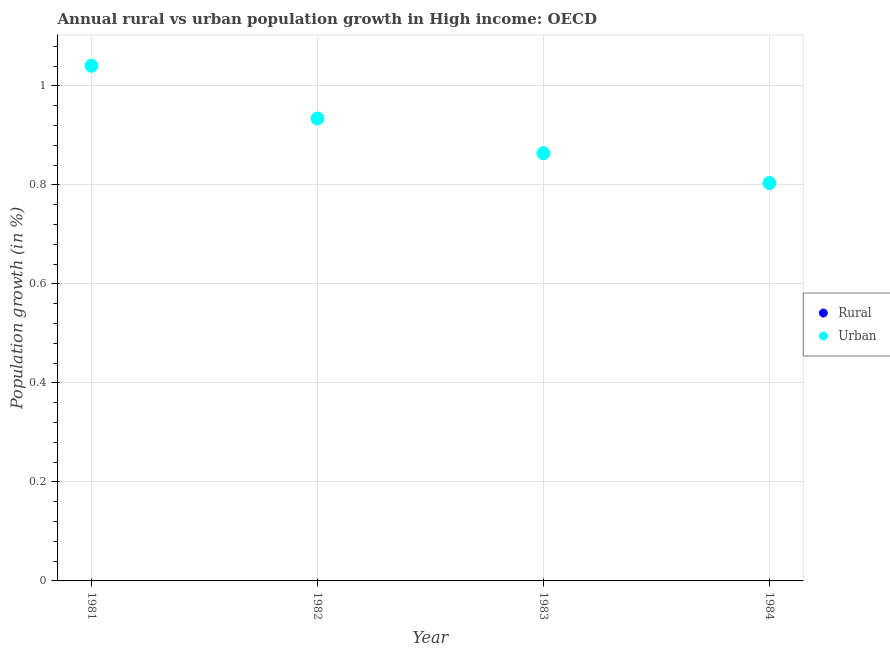Is the number of dotlines equal to the number of legend labels?
Your answer should be compact. No. What is the urban population growth in 1981?
Your answer should be very brief. 1.04. Across all years, what is the maximum urban population growth?
Your answer should be very brief. 1.04. Across all years, what is the minimum urban population growth?
Keep it short and to the point. 0.8. What is the difference between the urban population growth in 1981 and that in 1983?
Your answer should be compact. 0.18. What is the difference between the rural population growth in 1983 and the urban population growth in 1984?
Your answer should be compact. -0.8. In how many years, is the rural population growth greater than 1 %?
Ensure brevity in your answer.  0. What is the ratio of the urban population growth in 1981 to that in 1983?
Your response must be concise. 1.2. What is the difference between the highest and the second highest urban population growth?
Offer a terse response. 0.11. What is the difference between the highest and the lowest urban population growth?
Offer a terse response. 0.24. Is the sum of the urban population growth in 1981 and 1982 greater than the maximum rural population growth across all years?
Offer a very short reply. Yes. Does the urban population growth monotonically increase over the years?
Offer a very short reply. No. Is the urban population growth strictly greater than the rural population growth over the years?
Give a very brief answer. Yes. How many dotlines are there?
Offer a very short reply. 1. How many years are there in the graph?
Give a very brief answer. 4. What is the difference between two consecutive major ticks on the Y-axis?
Keep it short and to the point. 0.2. Does the graph contain any zero values?
Your answer should be very brief. Yes. Where does the legend appear in the graph?
Give a very brief answer. Center right. How many legend labels are there?
Offer a terse response. 2. How are the legend labels stacked?
Provide a short and direct response. Vertical. What is the title of the graph?
Keep it short and to the point. Annual rural vs urban population growth in High income: OECD. Does "Urban agglomerations" appear as one of the legend labels in the graph?
Ensure brevity in your answer.  No. What is the label or title of the Y-axis?
Offer a terse response. Population growth (in %). What is the Population growth (in %) in Rural in 1981?
Provide a short and direct response. 0. What is the Population growth (in %) in Urban  in 1981?
Your answer should be compact. 1.04. What is the Population growth (in %) of Urban  in 1982?
Your response must be concise. 0.93. What is the Population growth (in %) in Rural in 1983?
Provide a short and direct response. 0. What is the Population growth (in %) of Urban  in 1983?
Keep it short and to the point. 0.86. What is the Population growth (in %) in Rural in 1984?
Your answer should be very brief. 0. What is the Population growth (in %) in Urban  in 1984?
Provide a short and direct response. 0.8. Across all years, what is the maximum Population growth (in %) in Urban ?
Your answer should be compact. 1.04. Across all years, what is the minimum Population growth (in %) of Urban ?
Your answer should be very brief. 0.8. What is the total Population growth (in %) of Urban  in the graph?
Your answer should be compact. 3.64. What is the difference between the Population growth (in %) in Urban  in 1981 and that in 1982?
Provide a short and direct response. 0.11. What is the difference between the Population growth (in %) of Urban  in 1981 and that in 1983?
Offer a terse response. 0.18. What is the difference between the Population growth (in %) in Urban  in 1981 and that in 1984?
Your answer should be compact. 0.24. What is the difference between the Population growth (in %) in Urban  in 1982 and that in 1983?
Keep it short and to the point. 0.07. What is the difference between the Population growth (in %) in Urban  in 1982 and that in 1984?
Make the answer very short. 0.13. What is the difference between the Population growth (in %) in Urban  in 1983 and that in 1984?
Make the answer very short. 0.06. What is the average Population growth (in %) in Rural per year?
Ensure brevity in your answer.  0. What is the average Population growth (in %) of Urban  per year?
Give a very brief answer. 0.91. What is the ratio of the Population growth (in %) in Urban  in 1981 to that in 1982?
Make the answer very short. 1.11. What is the ratio of the Population growth (in %) of Urban  in 1981 to that in 1983?
Give a very brief answer. 1.2. What is the ratio of the Population growth (in %) in Urban  in 1981 to that in 1984?
Give a very brief answer. 1.29. What is the ratio of the Population growth (in %) of Urban  in 1982 to that in 1983?
Provide a succinct answer. 1.08. What is the ratio of the Population growth (in %) of Urban  in 1982 to that in 1984?
Offer a terse response. 1.16. What is the ratio of the Population growth (in %) in Urban  in 1983 to that in 1984?
Offer a very short reply. 1.07. What is the difference between the highest and the second highest Population growth (in %) of Urban ?
Give a very brief answer. 0.11. What is the difference between the highest and the lowest Population growth (in %) of Urban ?
Offer a very short reply. 0.24. 